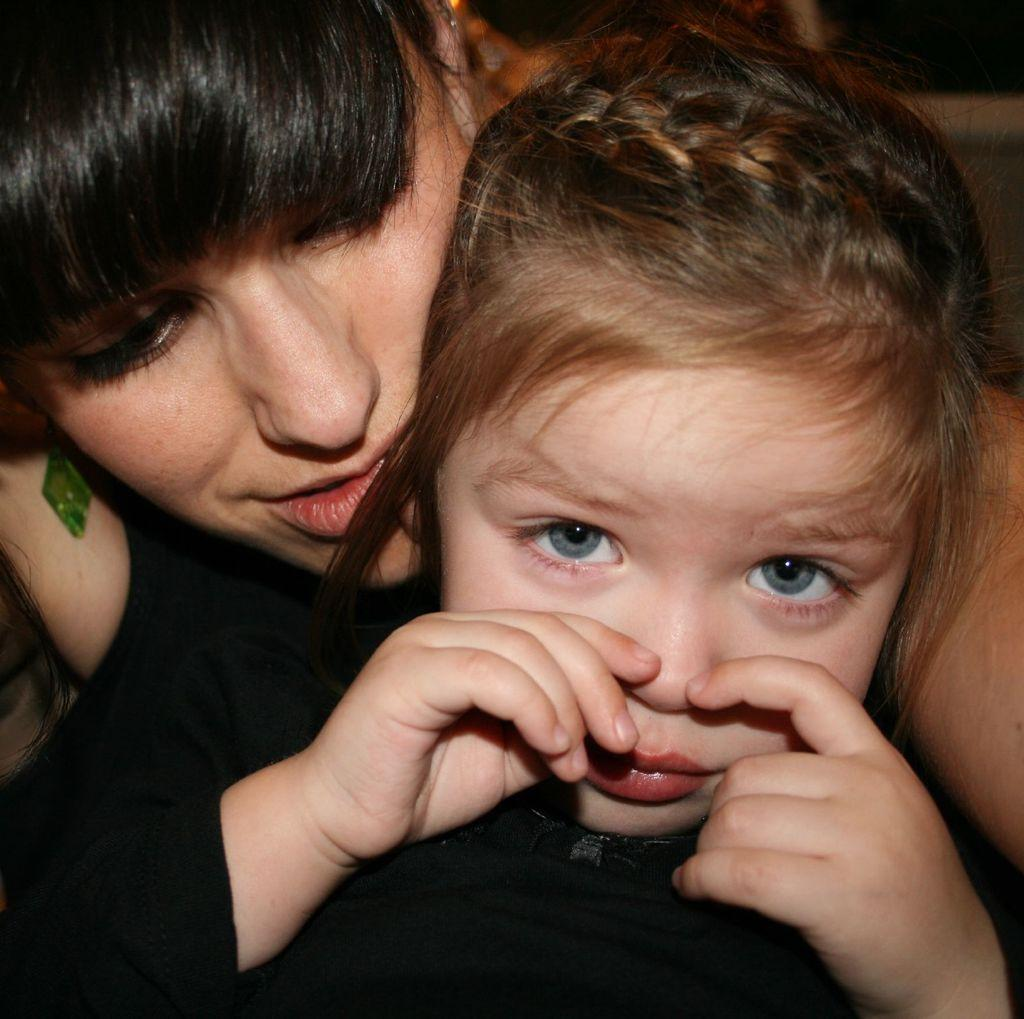How many people are in the image? There are two persons in the image. Can you describe the background of the image? The background of the image is blurry. What type of dog can be seen playing with a hen in the image? There is no dog or hen present in the image. What channel might be broadcasting the activities of the persons in the image? There is no reference to a channel or any broadcasting in the image, so it's not possible to determine what channel might be involved. 